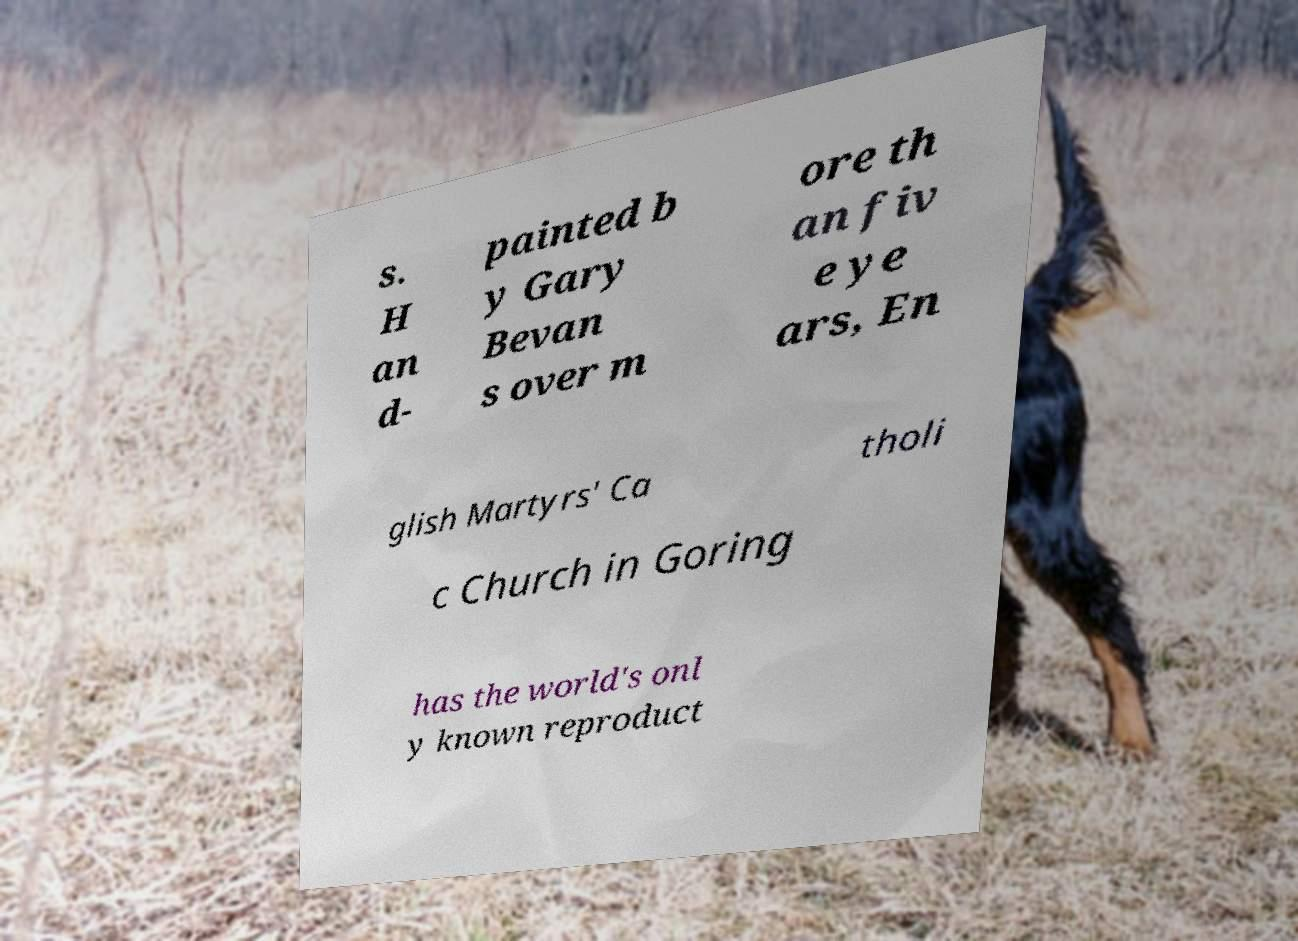What messages or text are displayed in this image? I need them in a readable, typed format. s. H an d- painted b y Gary Bevan s over m ore th an fiv e ye ars, En glish Martyrs' Ca tholi c Church in Goring has the world's onl y known reproduct 